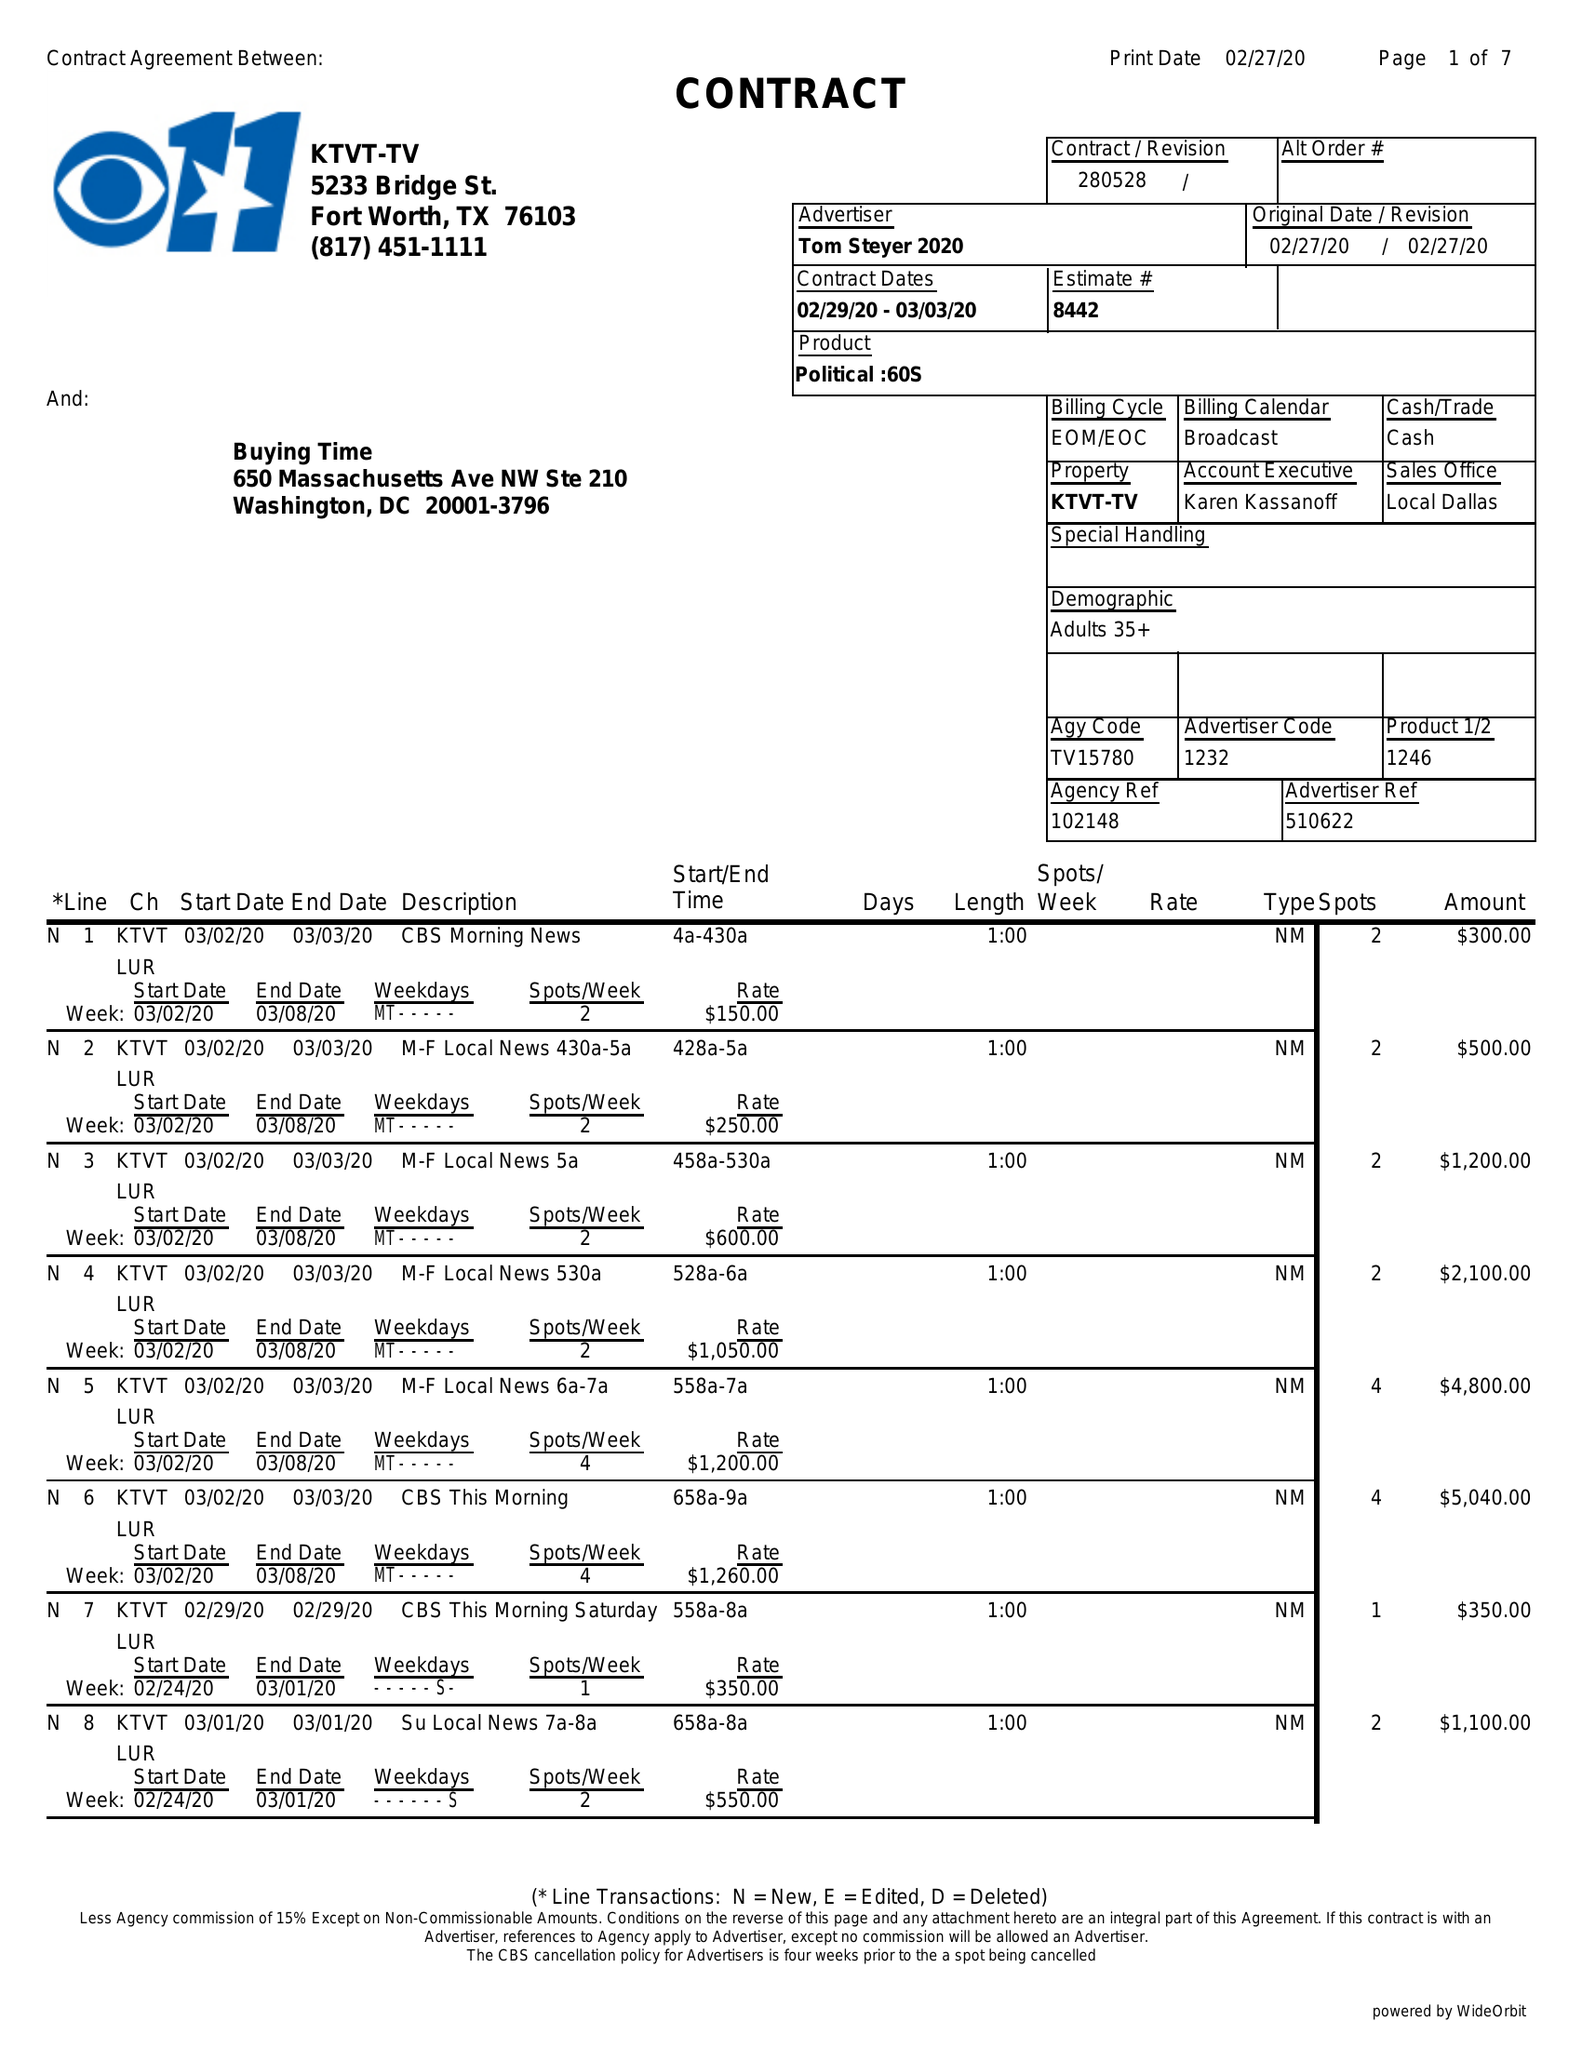What is the value for the advertiser?
Answer the question using a single word or phrase. TOM STEYER 2020 